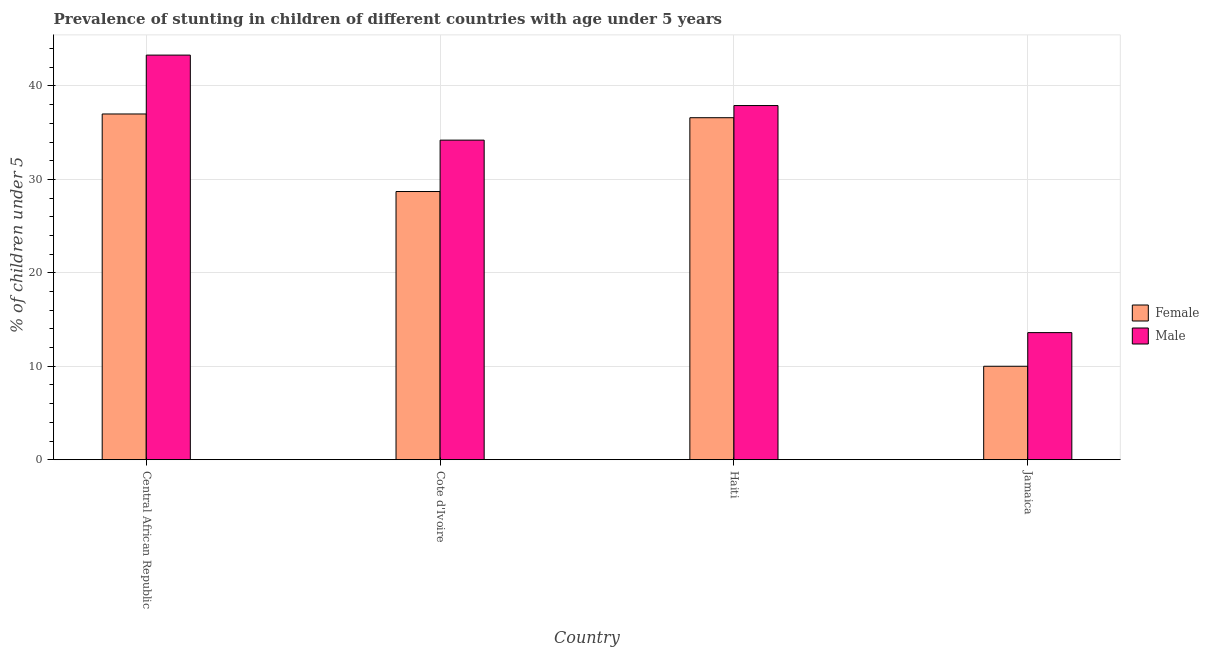Are the number of bars on each tick of the X-axis equal?
Ensure brevity in your answer.  Yes. How many bars are there on the 3rd tick from the right?
Your answer should be very brief. 2. What is the label of the 1st group of bars from the left?
Your answer should be compact. Central African Republic. Across all countries, what is the maximum percentage of stunted female children?
Offer a terse response. 37. Across all countries, what is the minimum percentage of stunted female children?
Offer a terse response. 10. In which country was the percentage of stunted male children maximum?
Ensure brevity in your answer.  Central African Republic. In which country was the percentage of stunted female children minimum?
Your answer should be very brief. Jamaica. What is the total percentage of stunted male children in the graph?
Your answer should be compact. 129. What is the difference between the percentage of stunted female children in Central African Republic and that in Haiti?
Offer a terse response. 0.4. What is the difference between the percentage of stunted female children in Haiti and the percentage of stunted male children in Central African Republic?
Make the answer very short. -6.7. What is the average percentage of stunted female children per country?
Your answer should be very brief. 28.07. What is the difference between the percentage of stunted male children and percentage of stunted female children in Haiti?
Offer a very short reply. 1.3. What is the difference between the highest and the second highest percentage of stunted female children?
Ensure brevity in your answer.  0.4. What is the difference between the highest and the lowest percentage of stunted male children?
Your answer should be very brief. 29.7. What does the 2nd bar from the right in Central African Republic represents?
Your answer should be very brief. Female. How many countries are there in the graph?
Offer a very short reply. 4. What is the difference between two consecutive major ticks on the Y-axis?
Your answer should be very brief. 10. Does the graph contain any zero values?
Your answer should be compact. No. Does the graph contain grids?
Make the answer very short. Yes. How many legend labels are there?
Your response must be concise. 2. What is the title of the graph?
Your response must be concise. Prevalence of stunting in children of different countries with age under 5 years. Does "Taxes on exports" appear as one of the legend labels in the graph?
Offer a terse response. No. What is the label or title of the Y-axis?
Make the answer very short.  % of children under 5. What is the  % of children under 5 of Female in Central African Republic?
Your answer should be very brief. 37. What is the  % of children under 5 in Male in Central African Republic?
Offer a terse response. 43.3. What is the  % of children under 5 of Female in Cote d'Ivoire?
Provide a succinct answer. 28.7. What is the  % of children under 5 in Male in Cote d'Ivoire?
Offer a terse response. 34.2. What is the  % of children under 5 of Female in Haiti?
Your answer should be compact. 36.6. What is the  % of children under 5 of Male in Haiti?
Your answer should be very brief. 37.9. What is the  % of children under 5 in Female in Jamaica?
Provide a short and direct response. 10. What is the  % of children under 5 of Male in Jamaica?
Make the answer very short. 13.6. Across all countries, what is the maximum  % of children under 5 of Male?
Offer a terse response. 43.3. Across all countries, what is the minimum  % of children under 5 of Female?
Offer a terse response. 10. Across all countries, what is the minimum  % of children under 5 in Male?
Your response must be concise. 13.6. What is the total  % of children under 5 in Female in the graph?
Give a very brief answer. 112.3. What is the total  % of children under 5 in Male in the graph?
Ensure brevity in your answer.  129. What is the difference between the  % of children under 5 in Female in Central African Republic and that in Cote d'Ivoire?
Provide a succinct answer. 8.3. What is the difference between the  % of children under 5 in Female in Central African Republic and that in Haiti?
Offer a terse response. 0.4. What is the difference between the  % of children under 5 of Male in Central African Republic and that in Haiti?
Provide a succinct answer. 5.4. What is the difference between the  % of children under 5 of Male in Central African Republic and that in Jamaica?
Make the answer very short. 29.7. What is the difference between the  % of children under 5 in Female in Cote d'Ivoire and that in Haiti?
Your response must be concise. -7.9. What is the difference between the  % of children under 5 of Female in Cote d'Ivoire and that in Jamaica?
Offer a terse response. 18.7. What is the difference between the  % of children under 5 of Male in Cote d'Ivoire and that in Jamaica?
Your response must be concise. 20.6. What is the difference between the  % of children under 5 in Female in Haiti and that in Jamaica?
Your answer should be compact. 26.6. What is the difference between the  % of children under 5 of Male in Haiti and that in Jamaica?
Offer a very short reply. 24.3. What is the difference between the  % of children under 5 in Female in Central African Republic and the  % of children under 5 in Male in Haiti?
Ensure brevity in your answer.  -0.9. What is the difference between the  % of children under 5 of Female in Central African Republic and the  % of children under 5 of Male in Jamaica?
Provide a succinct answer. 23.4. What is the difference between the  % of children under 5 in Female in Cote d'Ivoire and the  % of children under 5 in Male in Jamaica?
Your answer should be very brief. 15.1. What is the difference between the  % of children under 5 in Female in Haiti and the  % of children under 5 in Male in Jamaica?
Ensure brevity in your answer.  23. What is the average  % of children under 5 of Female per country?
Provide a succinct answer. 28.07. What is the average  % of children under 5 in Male per country?
Ensure brevity in your answer.  32.25. What is the difference between the  % of children under 5 of Female and  % of children under 5 of Male in Central African Republic?
Your answer should be compact. -6.3. What is the difference between the  % of children under 5 of Female and  % of children under 5 of Male in Haiti?
Offer a terse response. -1.3. What is the difference between the  % of children under 5 of Female and  % of children under 5 of Male in Jamaica?
Your answer should be compact. -3.6. What is the ratio of the  % of children under 5 of Female in Central African Republic to that in Cote d'Ivoire?
Provide a short and direct response. 1.29. What is the ratio of the  % of children under 5 in Male in Central African Republic to that in Cote d'Ivoire?
Offer a terse response. 1.27. What is the ratio of the  % of children under 5 of Female in Central African Republic to that in Haiti?
Provide a succinct answer. 1.01. What is the ratio of the  % of children under 5 of Male in Central African Republic to that in Haiti?
Offer a very short reply. 1.14. What is the ratio of the  % of children under 5 in Male in Central African Republic to that in Jamaica?
Make the answer very short. 3.18. What is the ratio of the  % of children under 5 in Female in Cote d'Ivoire to that in Haiti?
Your response must be concise. 0.78. What is the ratio of the  % of children under 5 in Male in Cote d'Ivoire to that in Haiti?
Offer a very short reply. 0.9. What is the ratio of the  % of children under 5 of Female in Cote d'Ivoire to that in Jamaica?
Keep it short and to the point. 2.87. What is the ratio of the  % of children under 5 in Male in Cote d'Ivoire to that in Jamaica?
Give a very brief answer. 2.51. What is the ratio of the  % of children under 5 in Female in Haiti to that in Jamaica?
Your answer should be compact. 3.66. What is the ratio of the  % of children under 5 in Male in Haiti to that in Jamaica?
Offer a very short reply. 2.79. What is the difference between the highest and the lowest  % of children under 5 in Female?
Give a very brief answer. 27. What is the difference between the highest and the lowest  % of children under 5 in Male?
Provide a succinct answer. 29.7. 